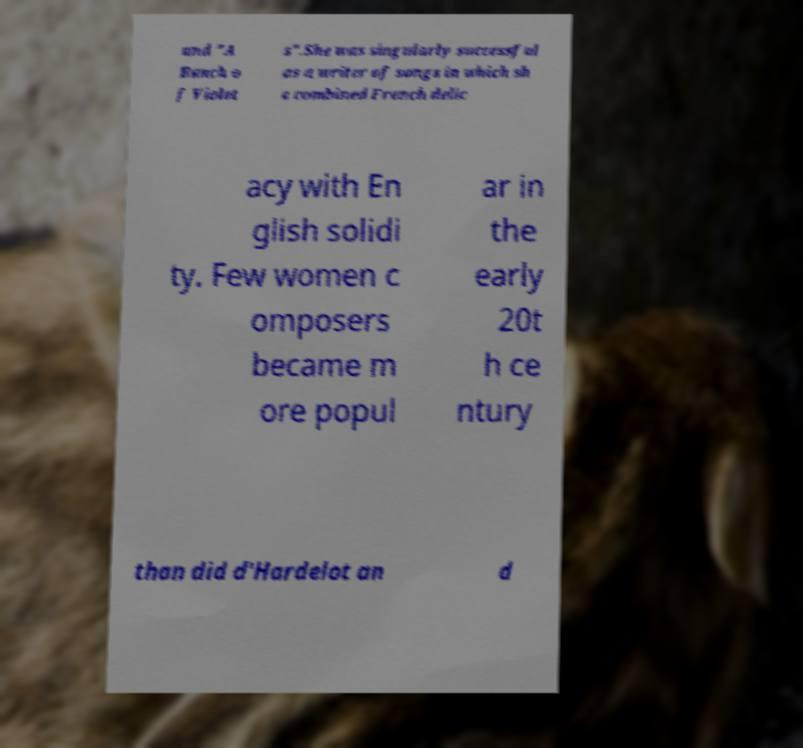Can you read and provide the text displayed in the image?This photo seems to have some interesting text. Can you extract and type it out for me? and "A Bunch o f Violet s".She was singularly successful as a writer of songs in which sh e combined French delic acy with En glish solidi ty. Few women c omposers became m ore popul ar in the early 20t h ce ntury than did d'Hardelot an d 